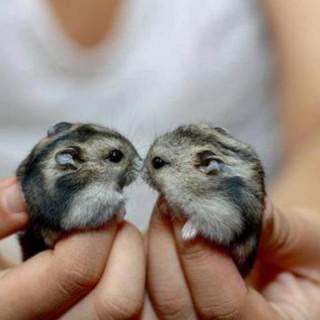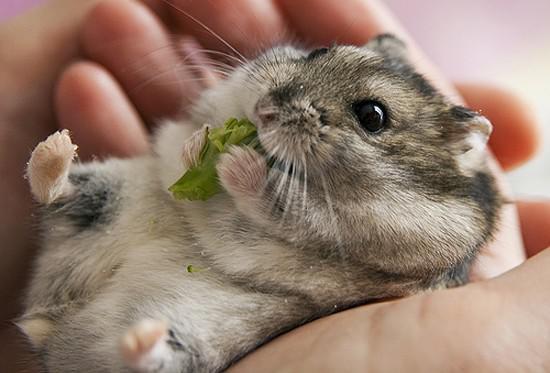The first image is the image on the left, the second image is the image on the right. For the images shown, is this caption "Has atleast one picture of an animal licking a finger" true? Answer yes or no. No. The first image is the image on the left, the second image is the image on the right. Given the left and right images, does the statement "One of the images clearly shows a hamster's tongue licking someone's finger." hold true? Answer yes or no. No. 